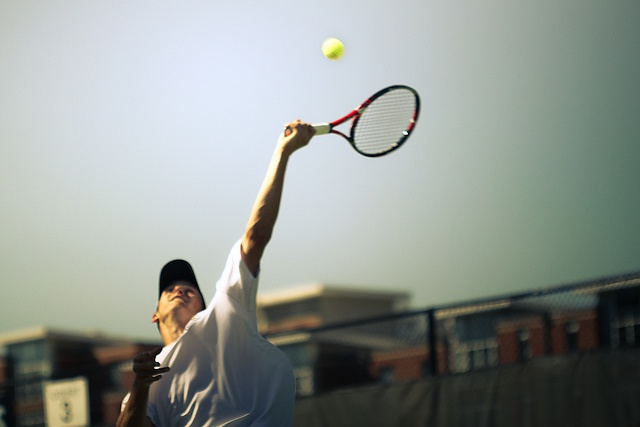Describe the objects in this image and their specific colors. I can see people in lightgray, gray, and black tones, tennis racket in lightgray, darkgray, black, and gray tones, and sports ball in lightgray, lightyellow, khaki, and olive tones in this image. 